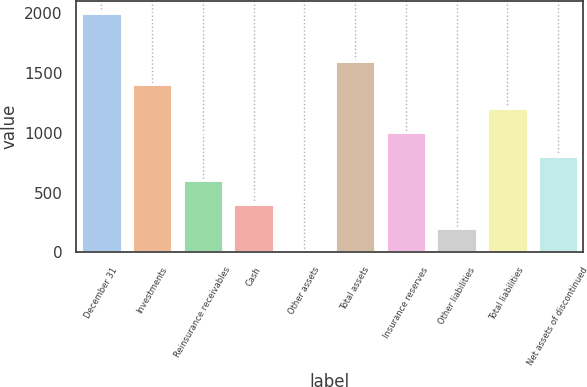Convert chart. <chart><loc_0><loc_0><loc_500><loc_500><bar_chart><fcel>December 31<fcel>Investments<fcel>Reinsurance receivables<fcel>Cash<fcel>Other assets<fcel>Total assets<fcel>Insurance reserves<fcel>Other liabilities<fcel>Total liabilities<fcel>Net assets of discontinued<nl><fcel>2005<fcel>1405.3<fcel>605.7<fcel>405.8<fcel>6<fcel>1605.2<fcel>1005.5<fcel>205.9<fcel>1205.4<fcel>805.6<nl></chart> 